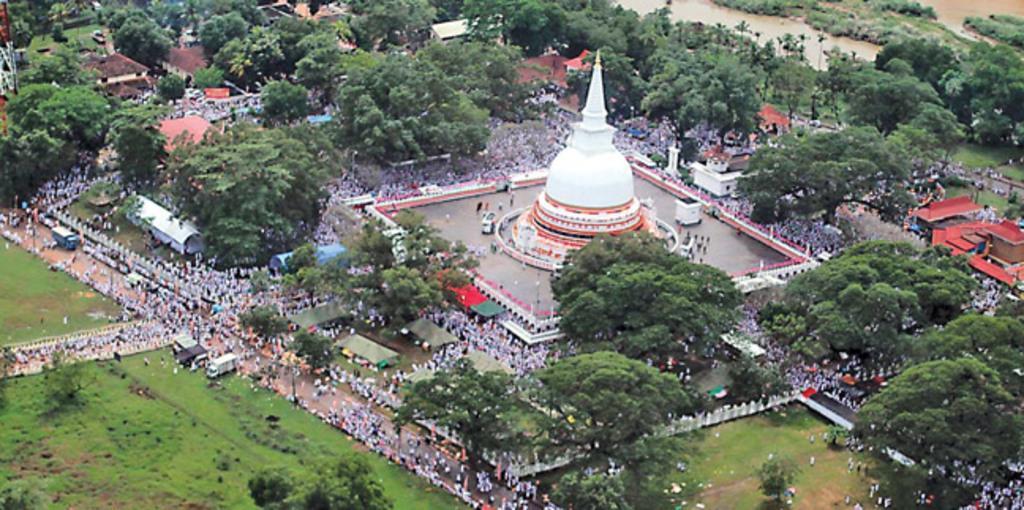Could you give a brief overview of what you see in this image? In this picture we can see the trees, buildings, fields, vehicles and various objects. In the center of the picture there are lot of people around a building. 